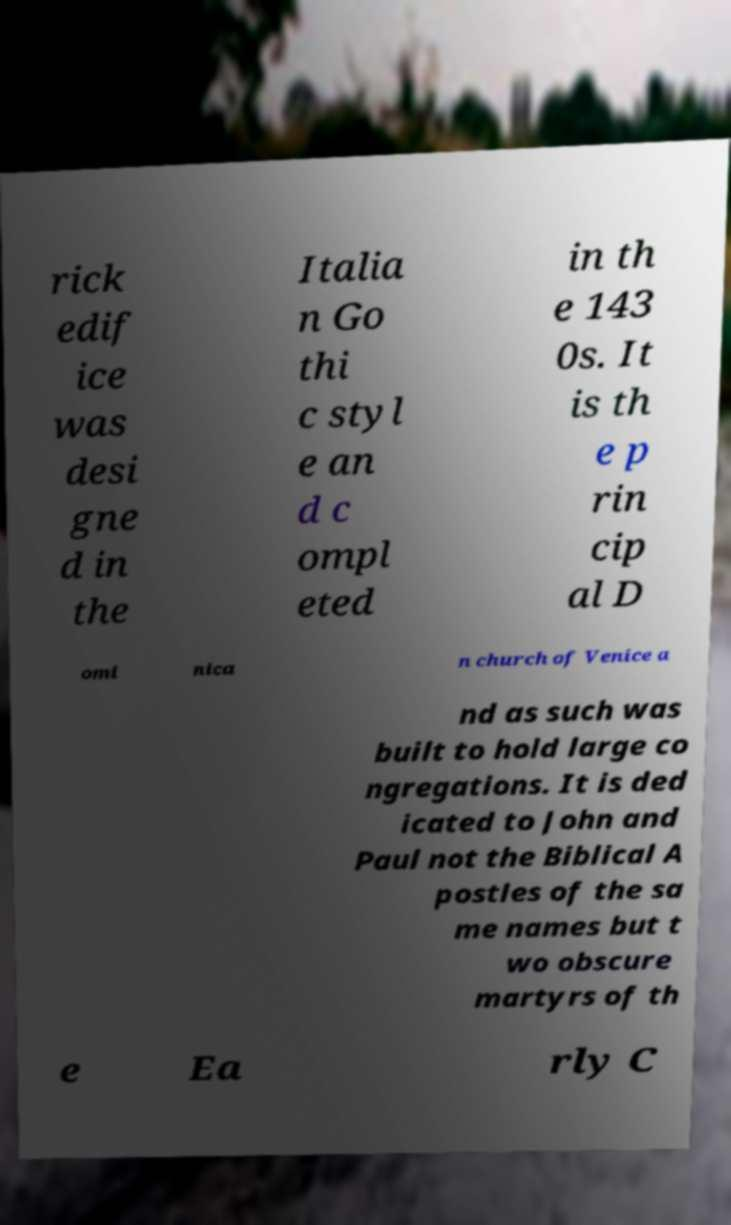What messages or text are displayed in this image? I need them in a readable, typed format. rick edif ice was desi gne d in the Italia n Go thi c styl e an d c ompl eted in th e 143 0s. It is th e p rin cip al D omi nica n church of Venice a nd as such was built to hold large co ngregations. It is ded icated to John and Paul not the Biblical A postles of the sa me names but t wo obscure martyrs of th e Ea rly C 